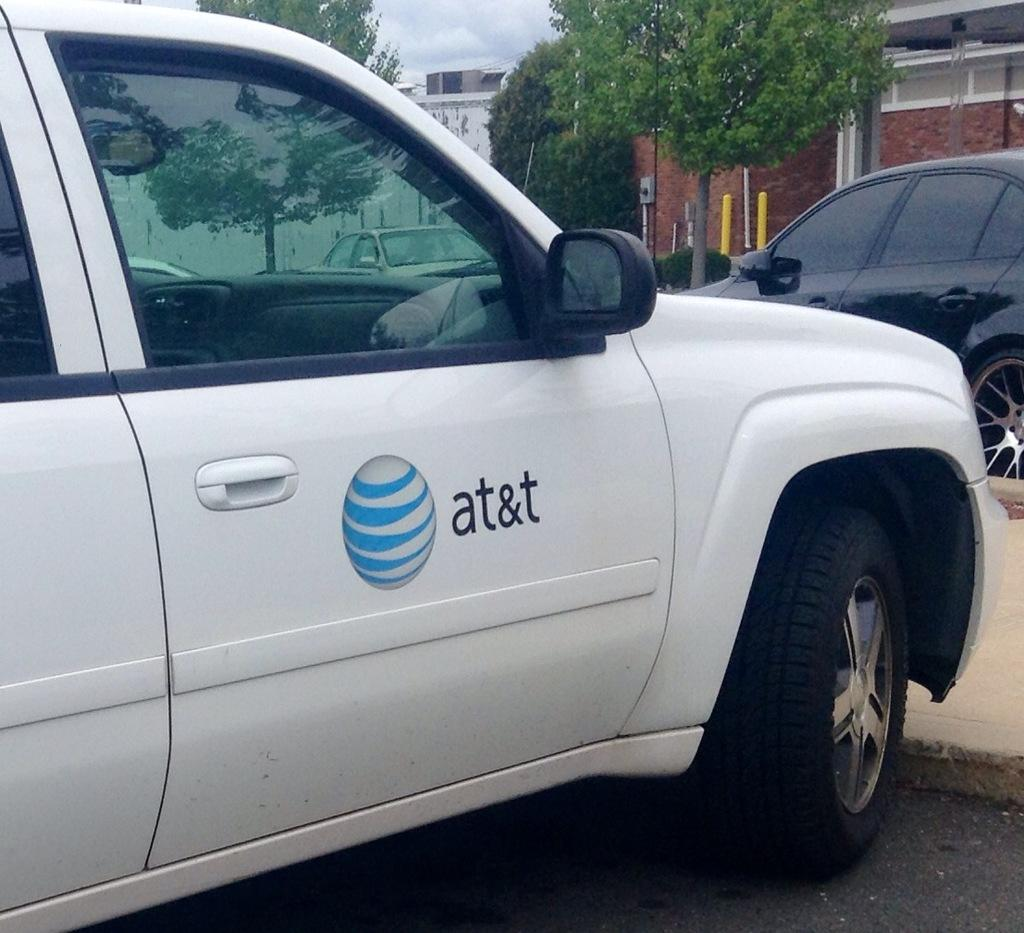What types of objects can be seen in the image? There are vehicles, trees, poles, and buildings in the image. What is visible in the background of the image? The sky is visible in the image. Are there any signs or indications of written information in the image? Yes, there is text or writing present in the image. What type of island is depicted in the image? There is no island present in the image. What religious symbols can be seen in the image? There are no religious symbols present in the image. 